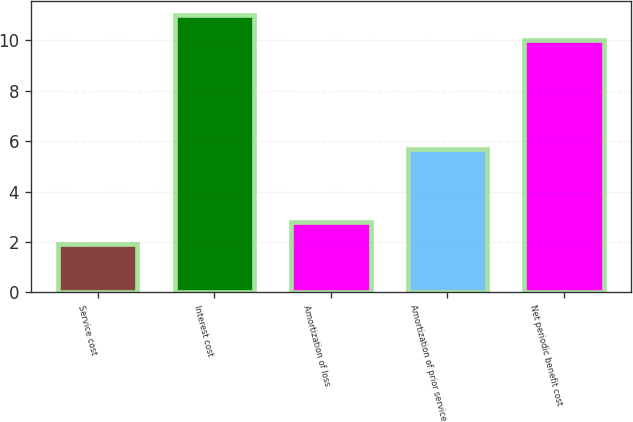Convert chart. <chart><loc_0><loc_0><loc_500><loc_500><bar_chart><fcel>Service cost<fcel>Interest cost<fcel>Amortization of loss<fcel>Amortization of prior service<fcel>Net periodic benefit cost<nl><fcel>1.9<fcel>11<fcel>2.81<fcel>5.7<fcel>10<nl></chart> 